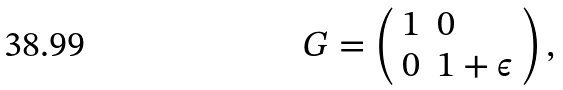<formula> <loc_0><loc_0><loc_500><loc_500>G = \left ( \begin{array} { l l } 1 & 0 \\ 0 & 1 + \epsilon \end{array} \right ) ,</formula> 